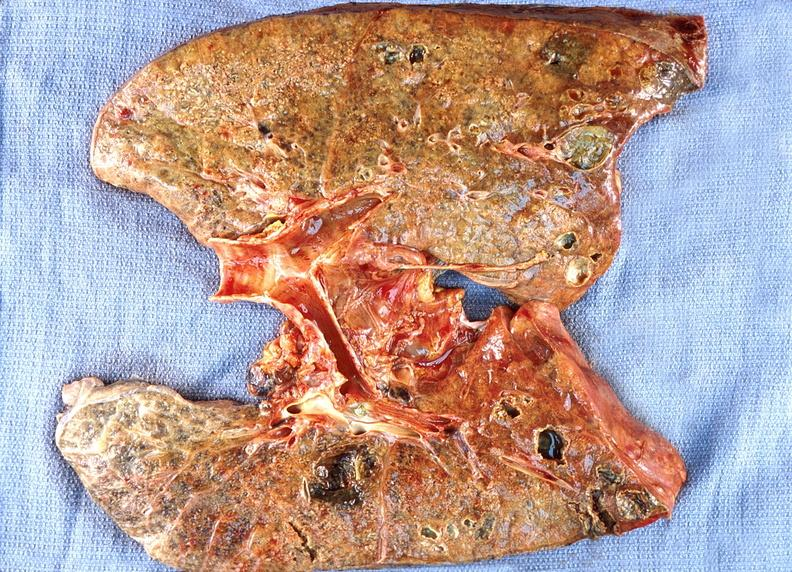where is this?
Answer the question using a single word or phrase. Lung 